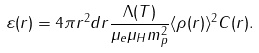Convert formula to latex. <formula><loc_0><loc_0><loc_500><loc_500>\varepsilon ( r ) = 4 \pi r ^ { 2 } d r \frac { \Lambda ( T ) } { \mu _ { e } \mu _ { H } m _ { p } ^ { 2 } } \langle \rho ( r ) \rangle ^ { 2 } C ( r ) .</formula> 